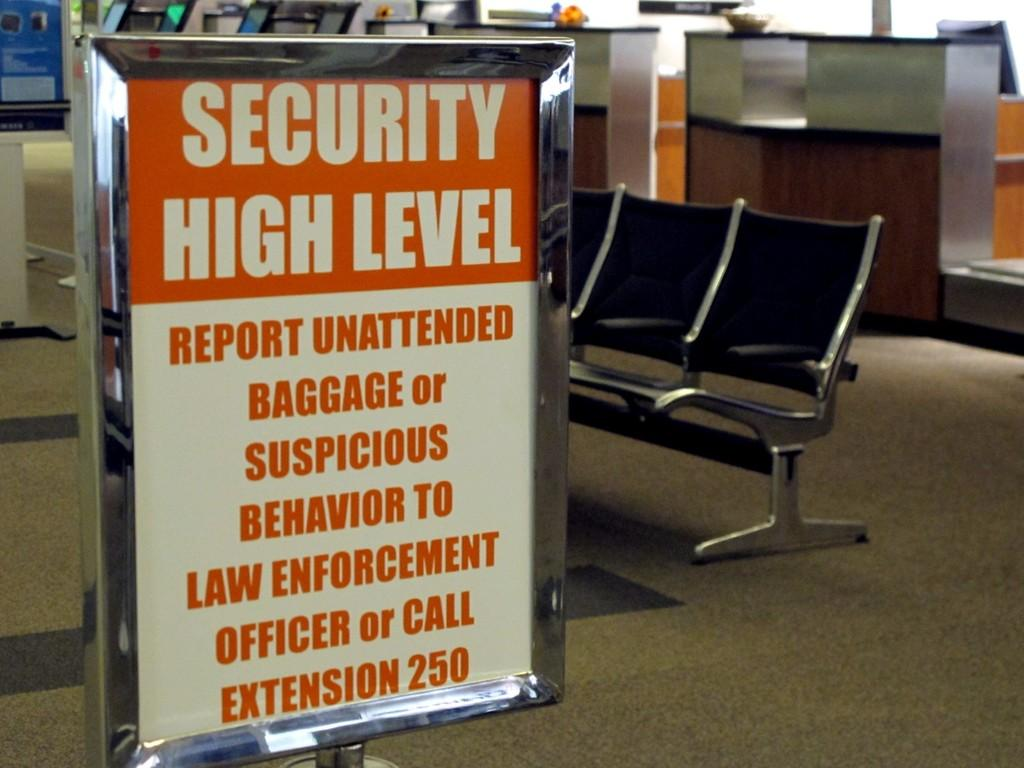<image>
Summarize the visual content of the image. White and red sign that tells people there is high levels of security. 